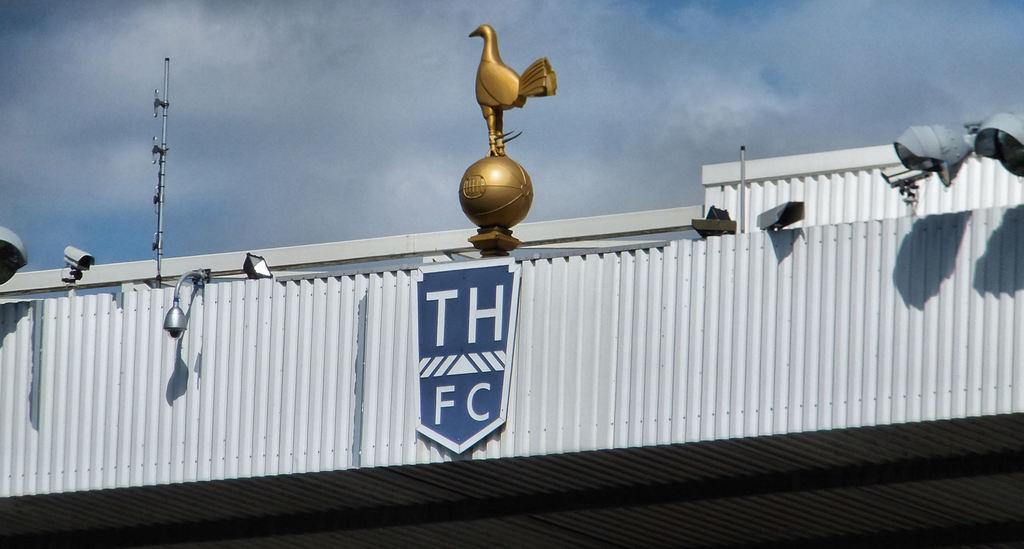What type of illumination is present in the image? There are lights in the image. What artistic creation can be seen in the image? There is a sculpture in the image. What tall structure is visible in the image? There is a tower in the image. What objects are located on the roof top? There are objects on the roof top. What is the flat, rectangular object in the image? There is a board in the image. What can be seen in the distance in the image? The sky is visible in the background of the image. Can you describe the grandfather's flesh in the image? There is no grandfather or flesh present in the image. Is the seashore visible in the image? The image does not depict a seashore; it features a tower, sculpture, lights, and other objects. 